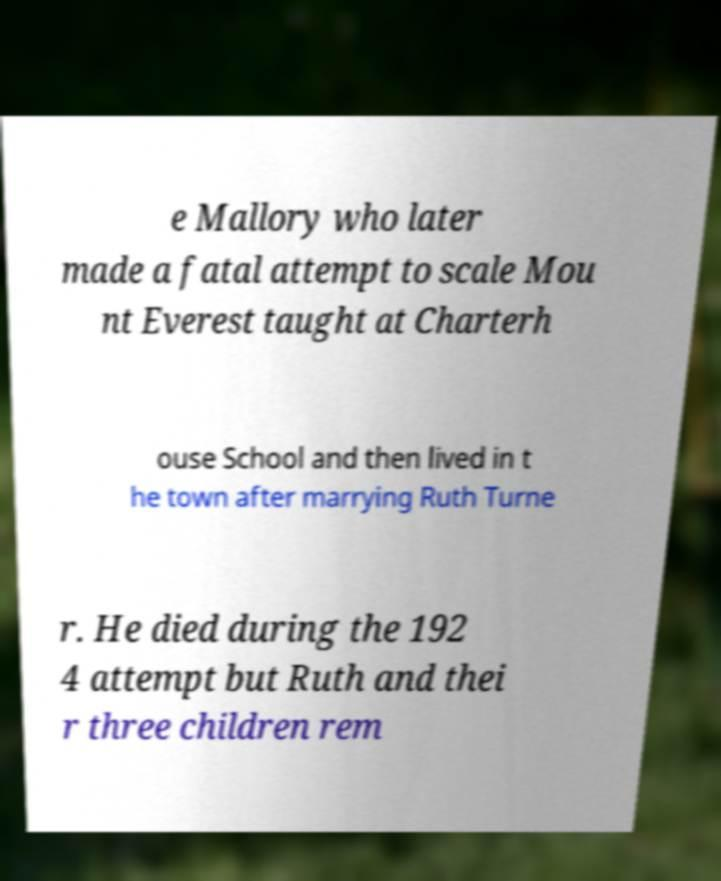What messages or text are displayed in this image? I need them in a readable, typed format. e Mallory who later made a fatal attempt to scale Mou nt Everest taught at Charterh ouse School and then lived in t he town after marrying Ruth Turne r. He died during the 192 4 attempt but Ruth and thei r three children rem 